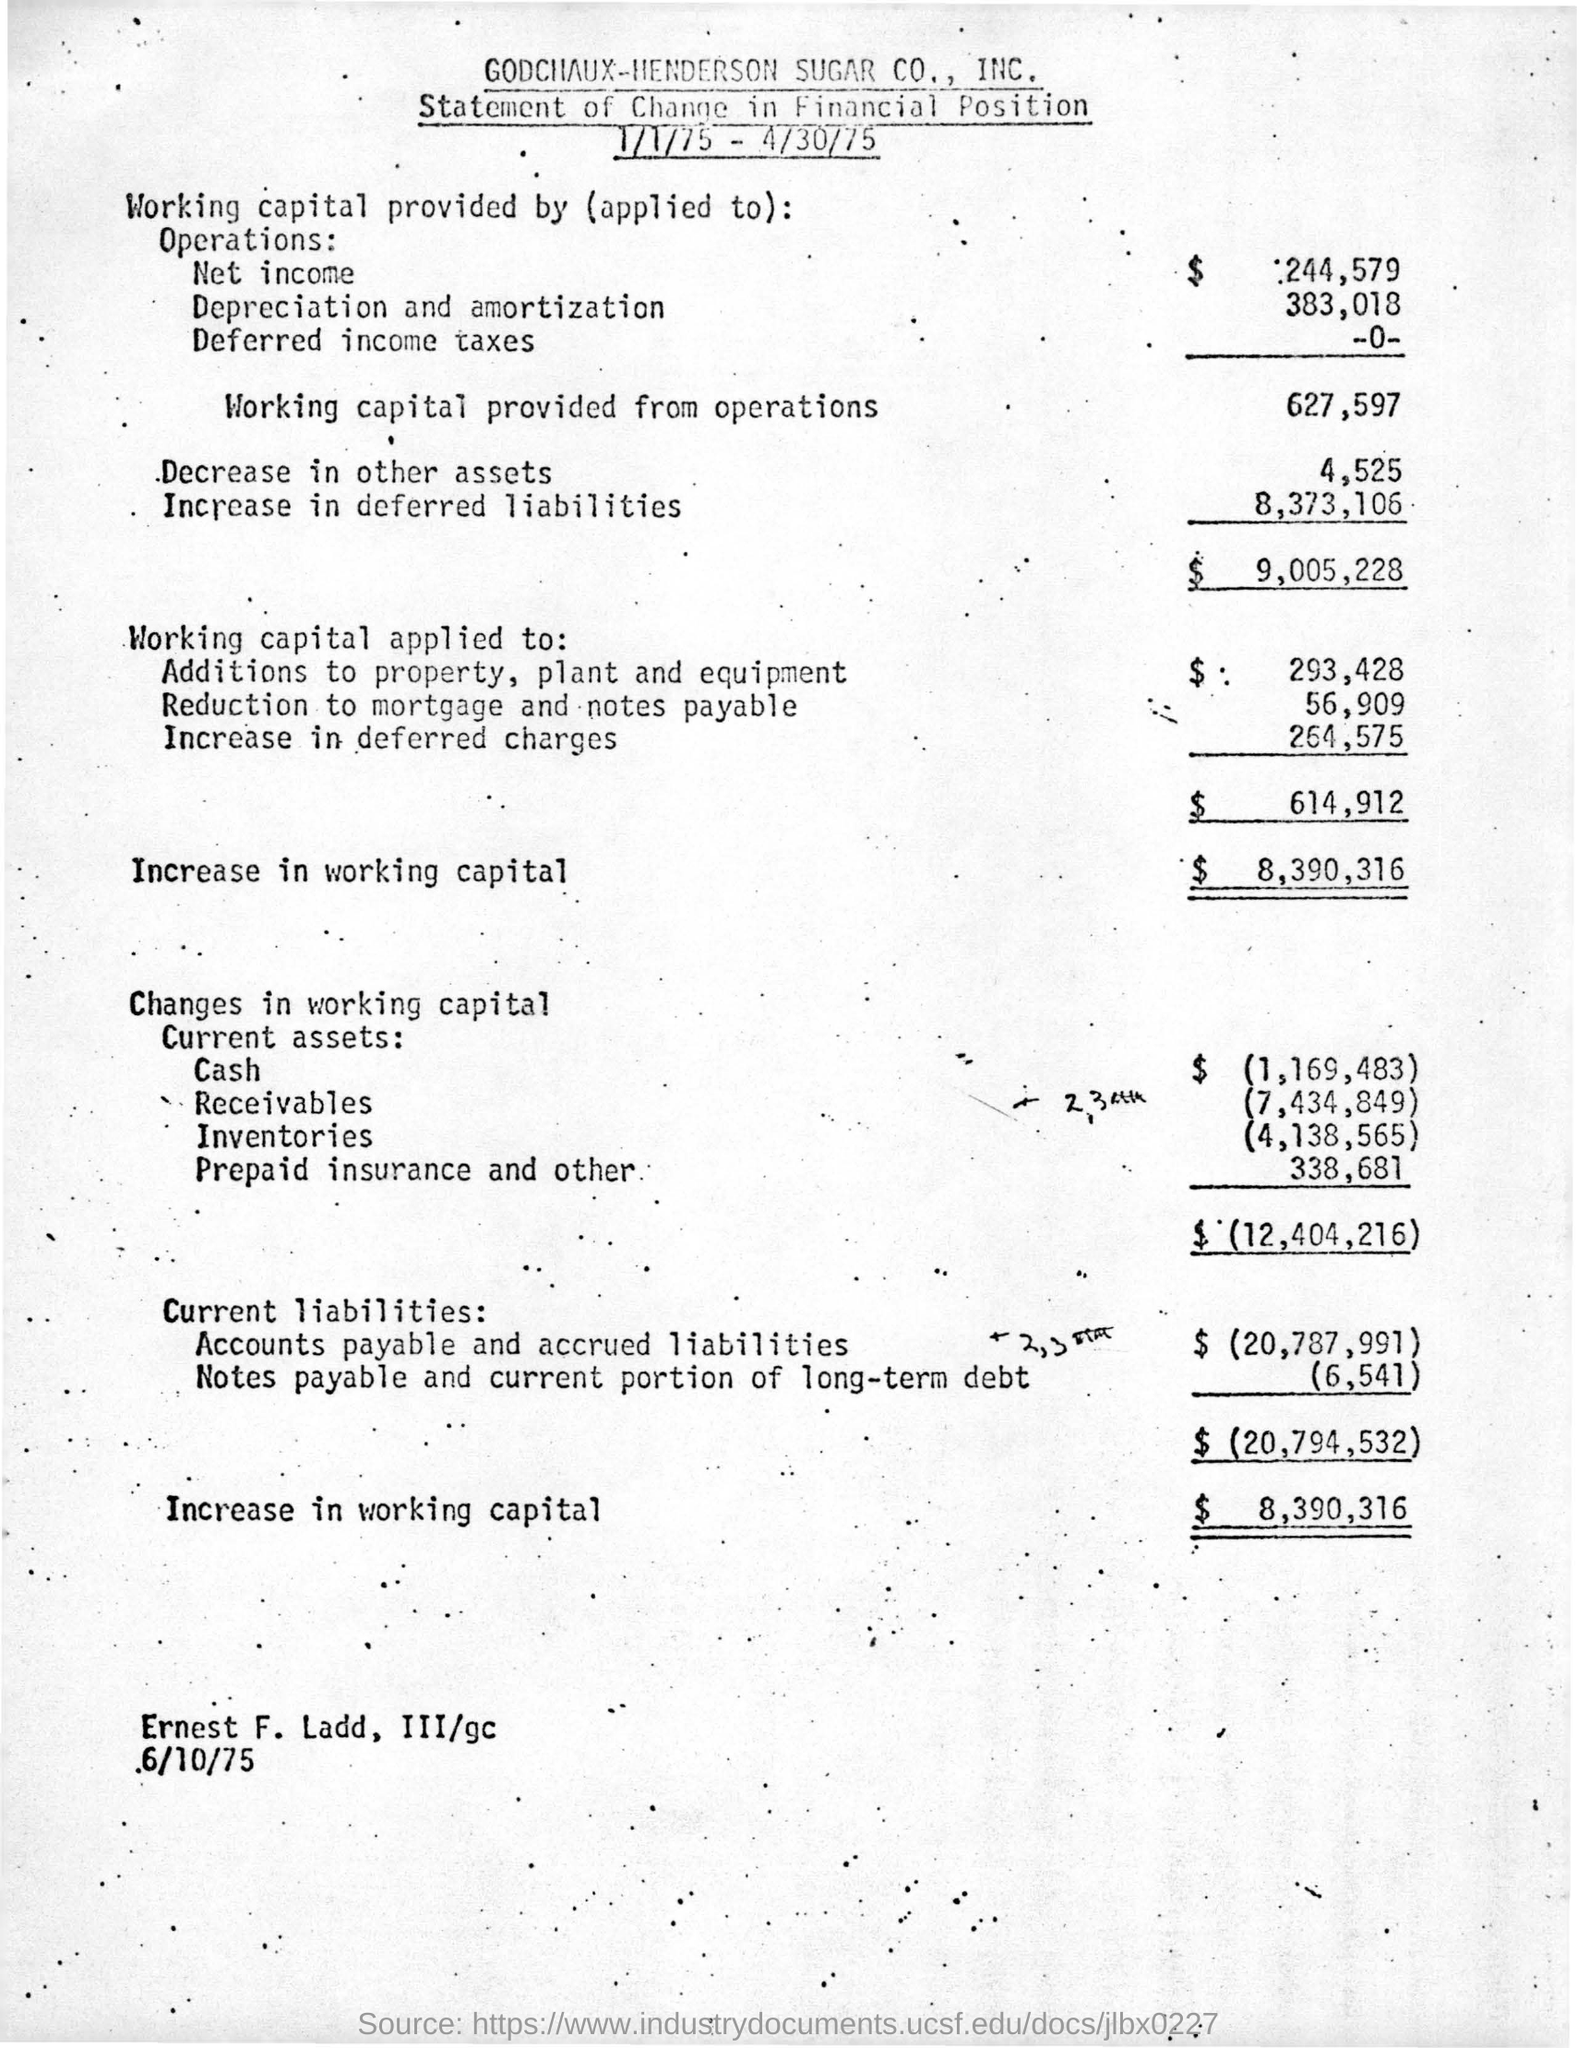What is the given amount in $ for the working capital provided from operations ?
Give a very brief answer. $627,597. What is the amount of increase in deferred charges in $?
Ensure brevity in your answer.  $264,575. What is the name of the given statement ?
Provide a succinct answer. Statement of change in financial position. What is the amount of increase in working capital in $ ?
Your response must be concise. $8,390,316. What is the net income for the working capital in the given statement ?
Provide a succinct answer. $244,579. What is the amount for prepaid insurance  and others in the statement ?
Your response must be concise. 338,681. Which company's statement is this?
Your response must be concise. GODCHAUX-HENDERSON SUGAR CO., INC. 